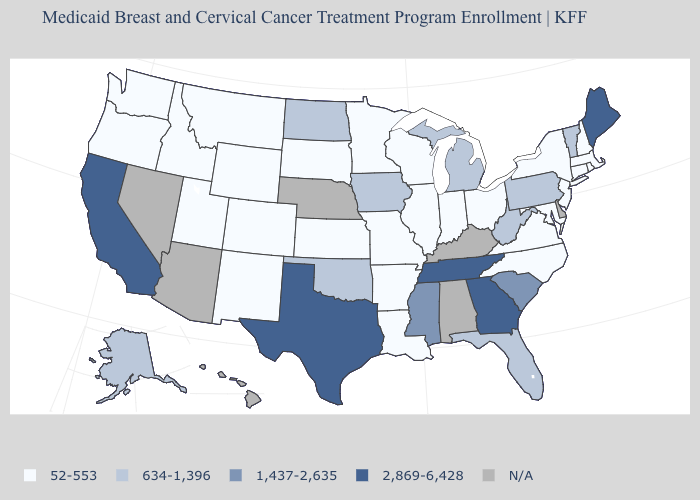Name the states that have a value in the range N/A?
Write a very short answer. Alabama, Arizona, Delaware, Hawaii, Kentucky, Nebraska, Nevada. Name the states that have a value in the range 1,437-2,635?
Concise answer only. Mississippi, South Carolina. Name the states that have a value in the range 634-1,396?
Answer briefly. Alaska, Florida, Iowa, Michigan, North Dakota, Oklahoma, Pennsylvania, Vermont, West Virginia. Which states have the highest value in the USA?
Write a very short answer. California, Georgia, Maine, Tennessee, Texas. What is the value of Hawaii?
Short answer required. N/A. Name the states that have a value in the range 1,437-2,635?
Quick response, please. Mississippi, South Carolina. What is the value of California?
Quick response, please. 2,869-6,428. What is the value of Pennsylvania?
Write a very short answer. 634-1,396. What is the highest value in the USA?
Short answer required. 2,869-6,428. What is the lowest value in the South?
Quick response, please. 52-553. Does the first symbol in the legend represent the smallest category?
Be succinct. Yes. Name the states that have a value in the range 52-553?
Concise answer only. Arkansas, Colorado, Connecticut, Idaho, Illinois, Indiana, Kansas, Louisiana, Maryland, Massachusetts, Minnesota, Missouri, Montana, New Hampshire, New Jersey, New Mexico, New York, North Carolina, Ohio, Oregon, Rhode Island, South Dakota, Utah, Virginia, Washington, Wisconsin, Wyoming. Which states have the lowest value in the USA?
Quick response, please. Arkansas, Colorado, Connecticut, Idaho, Illinois, Indiana, Kansas, Louisiana, Maryland, Massachusetts, Minnesota, Missouri, Montana, New Hampshire, New Jersey, New Mexico, New York, North Carolina, Ohio, Oregon, Rhode Island, South Dakota, Utah, Virginia, Washington, Wisconsin, Wyoming. Which states hav the highest value in the West?
Write a very short answer. California. Is the legend a continuous bar?
Concise answer only. No. 